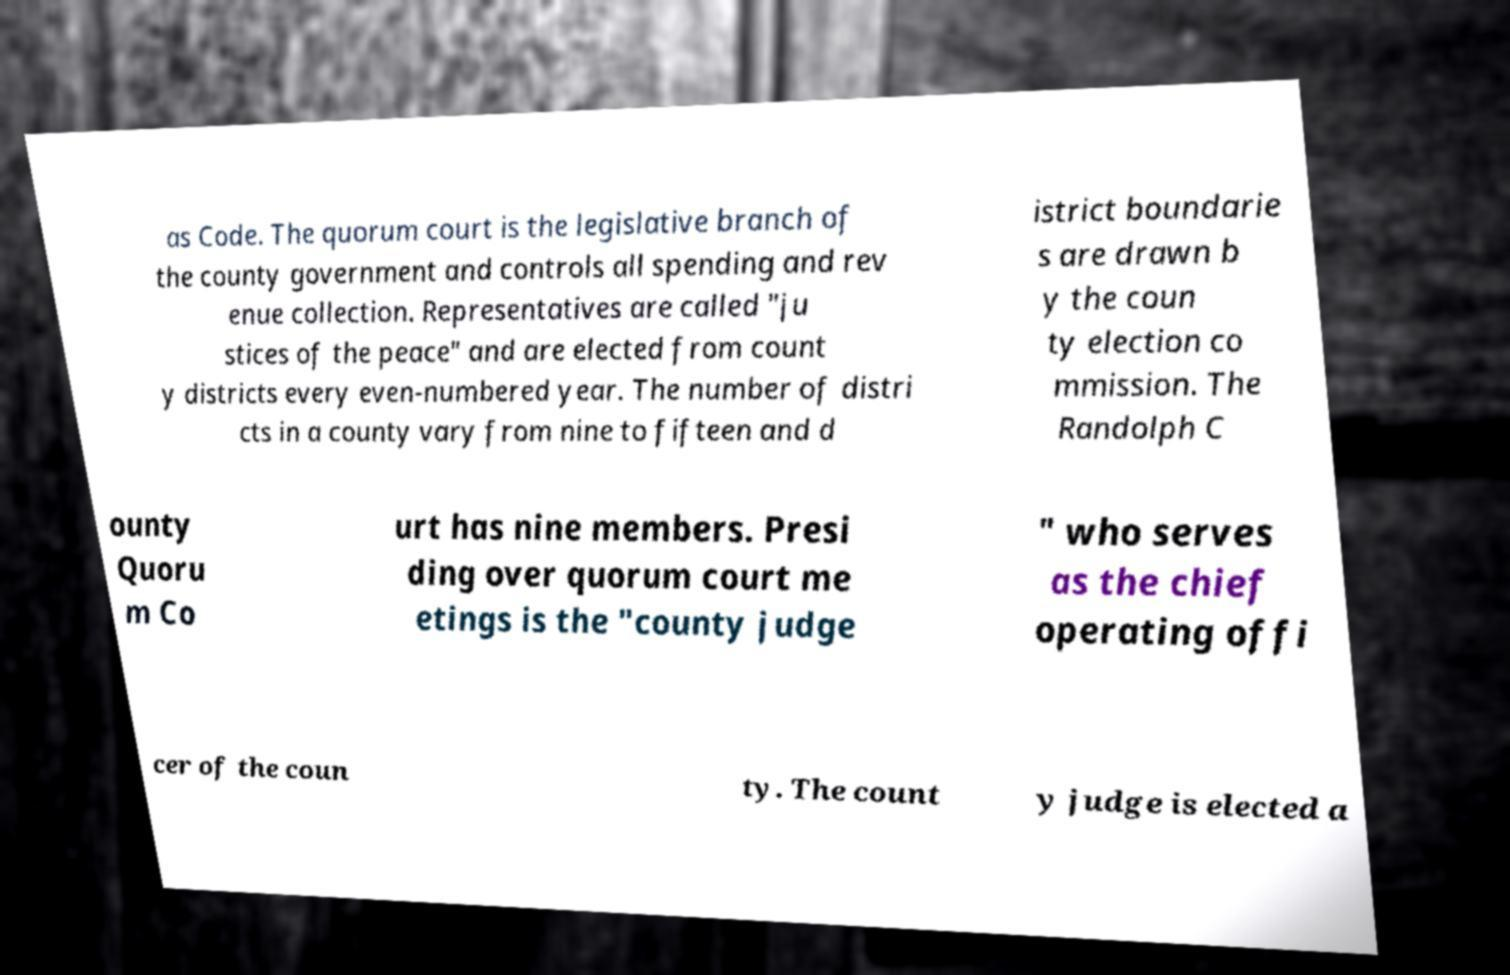Please read and relay the text visible in this image. What does it say? as Code. The quorum court is the legislative branch of the county government and controls all spending and rev enue collection. Representatives are called "ju stices of the peace" and are elected from count y districts every even-numbered year. The number of distri cts in a county vary from nine to fifteen and d istrict boundarie s are drawn b y the coun ty election co mmission. The Randolph C ounty Quoru m Co urt has nine members. Presi ding over quorum court me etings is the "county judge " who serves as the chief operating offi cer of the coun ty. The count y judge is elected a 